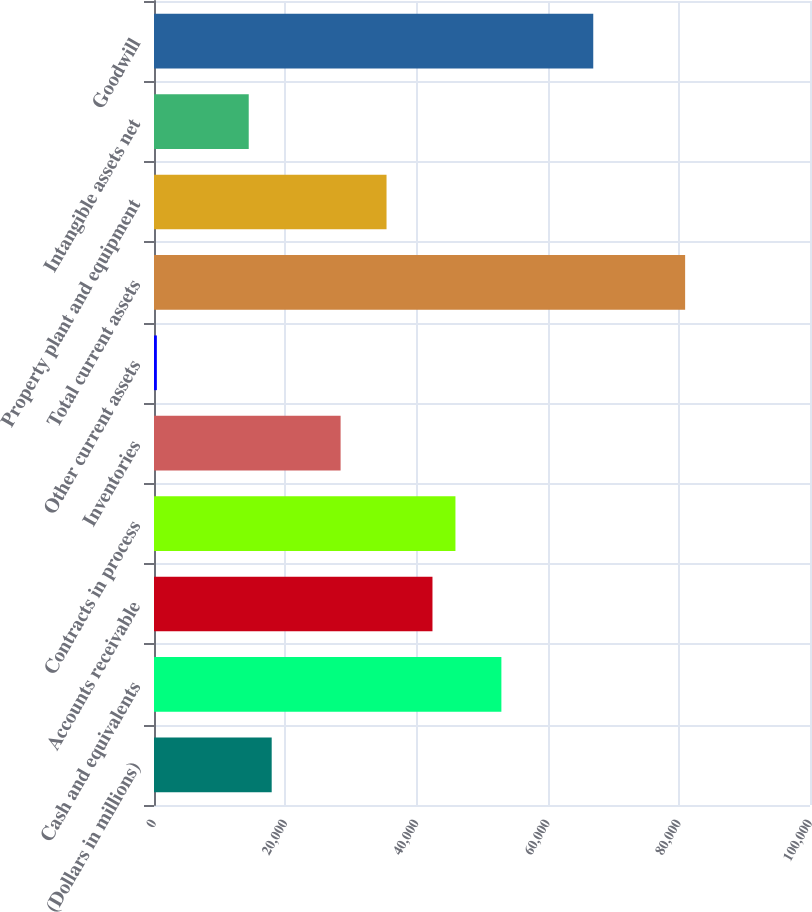<chart> <loc_0><loc_0><loc_500><loc_500><bar_chart><fcel>(Dollars in millions)<fcel>Cash and equivalents<fcel>Accounts receivable<fcel>Contracts in process<fcel>Inventories<fcel>Other current assets<fcel>Total current assets<fcel>Property plant and equipment<fcel>Intangible assets net<fcel>Goodwill<nl><fcel>17941.5<fcel>52954.5<fcel>42450.6<fcel>45951.9<fcel>28445.4<fcel>435<fcel>80964.9<fcel>35448<fcel>14440.2<fcel>66959.7<nl></chart> 